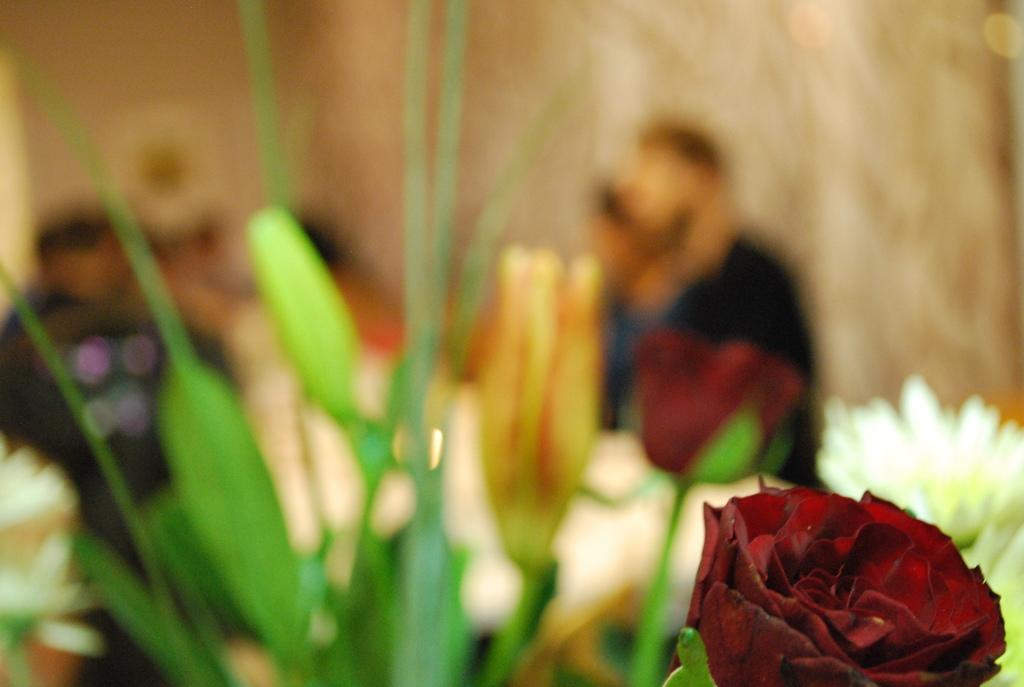What is located at the bottom of the image? There is a flower at the bottom of the image. How would you describe the background of the image? The background of the image is blurred. What can be seen in the background of the image? Plants, flowers, people, and objects are visible in the background. What type of meal are the friends sharing in the image? There are no people or meal present in the image; it only features a flower at the bottom and a blurred background with plants, flowers, and objects. Can you tell me how many snails are crawling on the flower in the image? There are no snails visible on the flower in the image. 